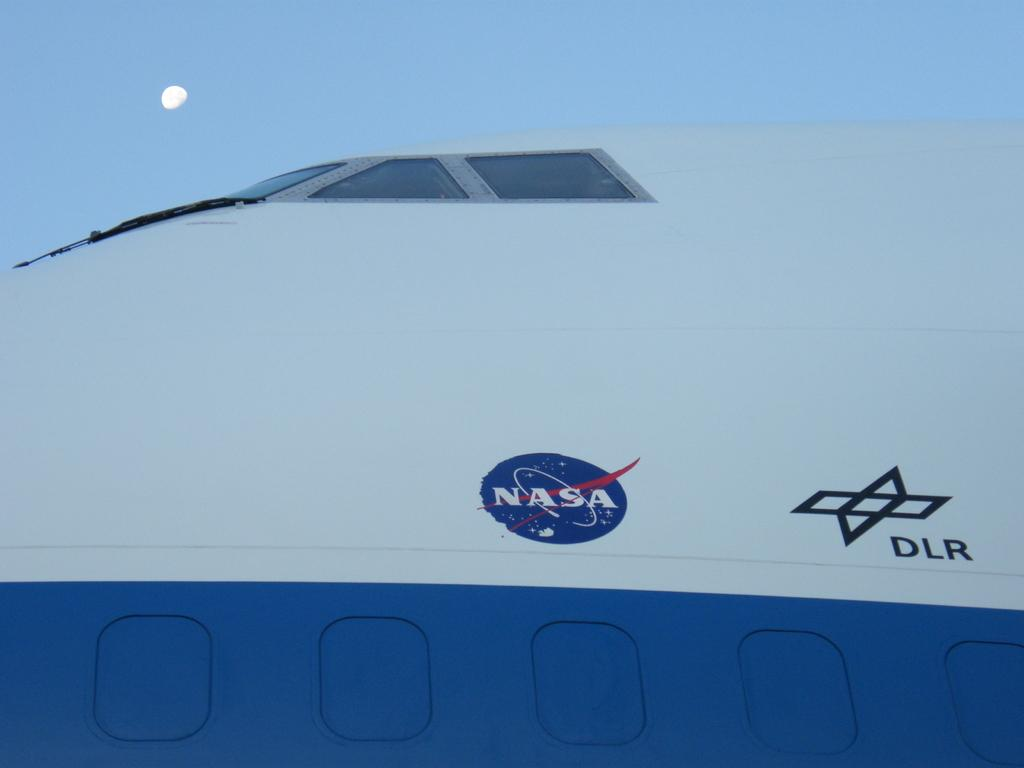Provide a one-sentence caption for the provided image. An upclose view of a NASA space shuttle. 